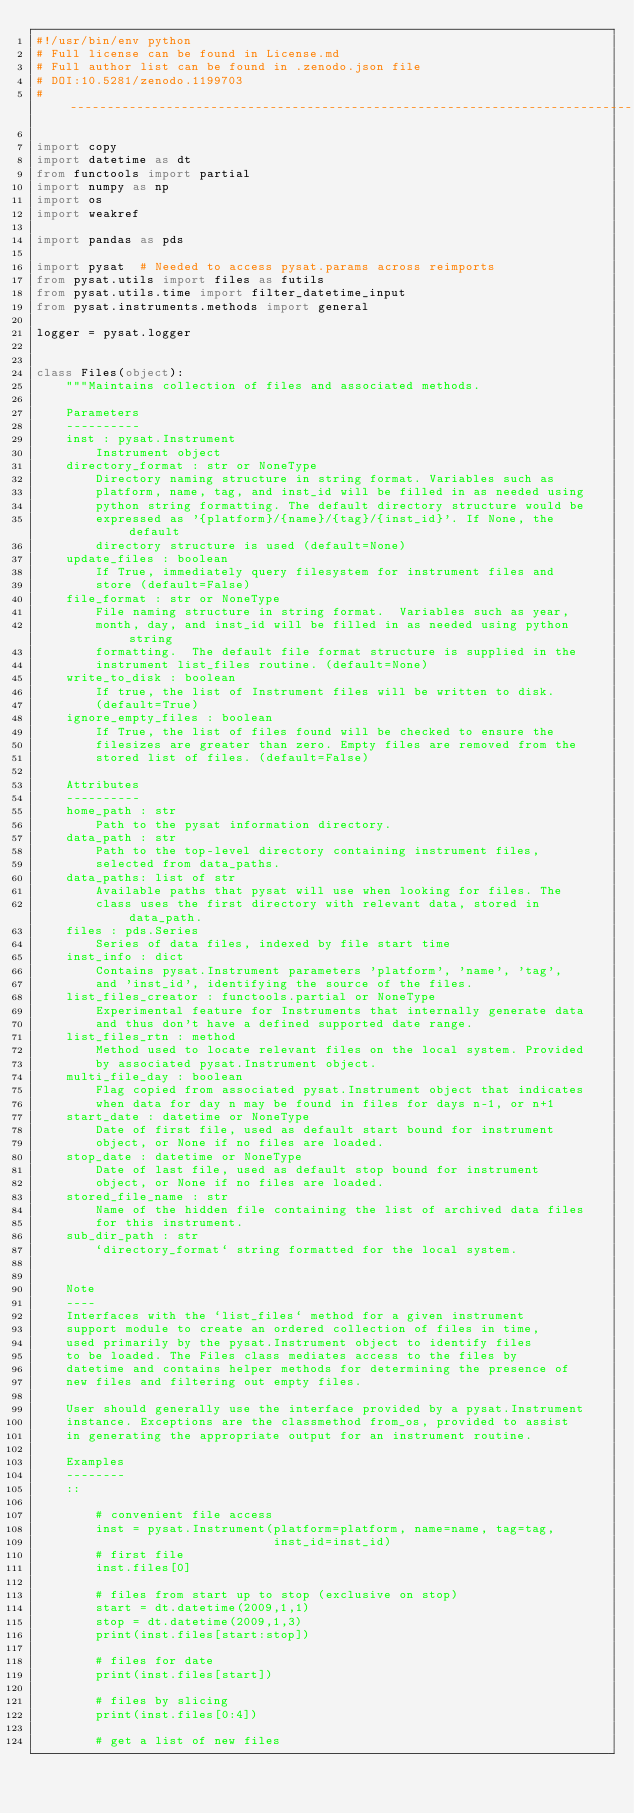Convert code to text. <code><loc_0><loc_0><loc_500><loc_500><_Python_>#!/usr/bin/env python
# Full license can be found in License.md
# Full author list can be found in .zenodo.json file
# DOI:10.5281/zenodo.1199703
# ----------------------------------------------------------------------------

import copy
import datetime as dt
from functools import partial
import numpy as np
import os
import weakref

import pandas as pds

import pysat  # Needed to access pysat.params across reimports
from pysat.utils import files as futils
from pysat.utils.time import filter_datetime_input
from pysat.instruments.methods import general

logger = pysat.logger


class Files(object):
    """Maintains collection of files and associated methods.

    Parameters
    ----------
    inst : pysat.Instrument
        Instrument object
    directory_format : str or NoneType
        Directory naming structure in string format. Variables such as
        platform, name, tag, and inst_id will be filled in as needed using
        python string formatting. The default directory structure would be
        expressed as '{platform}/{name}/{tag}/{inst_id}'. If None, the default
        directory structure is used (default=None)
    update_files : boolean
        If True, immediately query filesystem for instrument files and
        store (default=False)
    file_format : str or NoneType
        File naming structure in string format.  Variables such as year,
        month, day, and inst_id will be filled in as needed using python string
        formatting.  The default file format structure is supplied in the
        instrument list_files routine. (default=None)
    write_to_disk : boolean
        If true, the list of Instrument files will be written to disk.
        (default=True)
    ignore_empty_files : boolean
        If True, the list of files found will be checked to ensure the
        filesizes are greater than zero. Empty files are removed from the
        stored list of files. (default=False)

    Attributes
    ----------
    home_path : str
        Path to the pysat information directory.
    data_path : str
        Path to the top-level directory containing instrument files,
        selected from data_paths.
    data_paths: list of str
        Available paths that pysat will use when looking for files. The
        class uses the first directory with relevant data, stored in data_path.
    files : pds.Series
        Series of data files, indexed by file start time
    inst_info : dict
        Contains pysat.Instrument parameters 'platform', 'name', 'tag',
        and 'inst_id', identifying the source of the files.
    list_files_creator : functools.partial or NoneType
        Experimental feature for Instruments that internally generate data
        and thus don't have a defined supported date range.
    list_files_rtn : method
        Method used to locate relevant files on the local system. Provided
        by associated pysat.Instrument object.
    multi_file_day : boolean
        Flag copied from associated pysat.Instrument object that indicates
        when data for day n may be found in files for days n-1, or n+1
    start_date : datetime or NoneType
        Date of first file, used as default start bound for instrument
        object, or None if no files are loaded.
    stop_date : datetime or NoneType
        Date of last file, used as default stop bound for instrument
        object, or None if no files are loaded.
    stored_file_name : str
        Name of the hidden file containing the list of archived data files
        for this instrument.
    sub_dir_path : str
        `directory_format` string formatted for the local system.


    Note
    ----
    Interfaces with the `list_files` method for a given instrument
    support module to create an ordered collection of files in time,
    used primarily by the pysat.Instrument object to identify files
    to be loaded. The Files class mediates access to the files by
    datetime and contains helper methods for determining the presence of
    new files and filtering out empty files.

    User should generally use the interface provided by a pysat.Instrument
    instance. Exceptions are the classmethod from_os, provided to assist
    in generating the appropriate output for an instrument routine.

    Examples
    --------
    ::

        # convenient file access
        inst = pysat.Instrument(platform=platform, name=name, tag=tag,
                                inst_id=inst_id)
        # first file
        inst.files[0]

        # files from start up to stop (exclusive on stop)
        start = dt.datetime(2009,1,1)
        stop = dt.datetime(2009,1,3)
        print(inst.files[start:stop])

        # files for date
        print(inst.files[start])

        # files by slicing
        print(inst.files[0:4])

        # get a list of new files</code> 